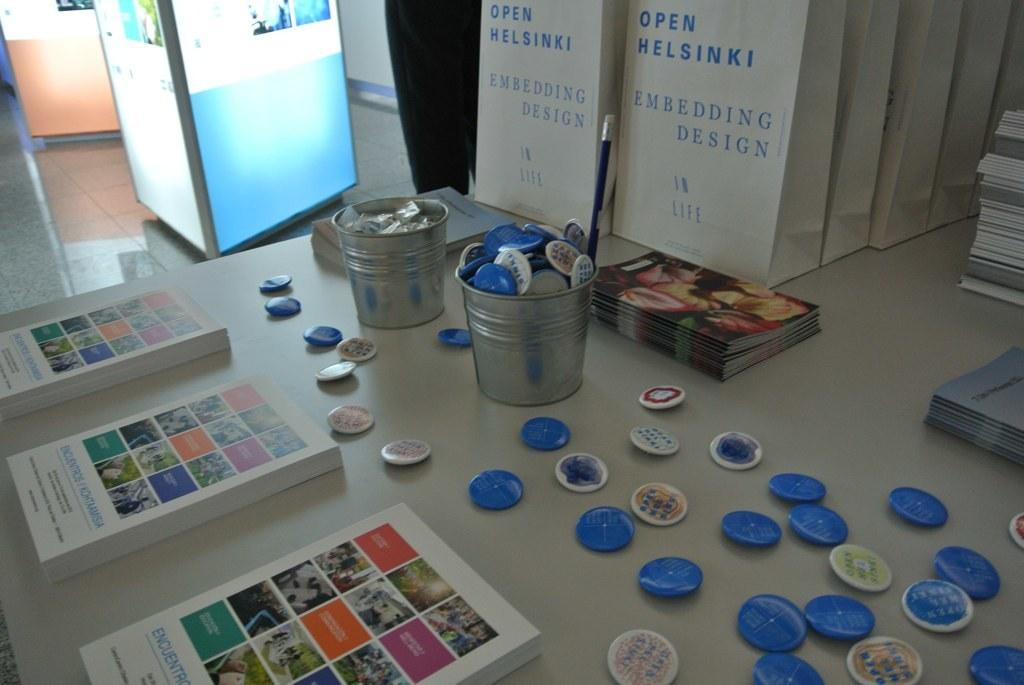<image>
Describe the image concisely. Buttons and books are neatly arranged on a table along with bags saying Open Helsinki Embedding Design. 